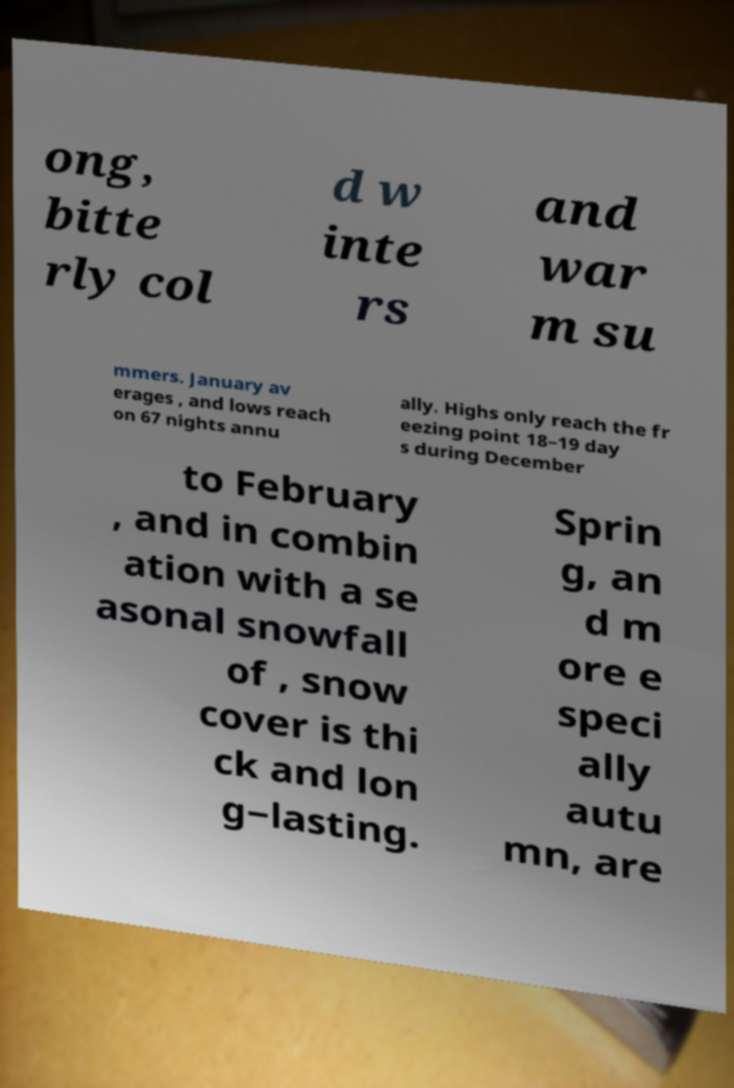There's text embedded in this image that I need extracted. Can you transcribe it verbatim? ong, bitte rly col d w inte rs and war m su mmers. January av erages , and lows reach on 67 nights annu ally. Highs only reach the fr eezing point 18–19 day s during December to February , and in combin ation with a se asonal snowfall of , snow cover is thi ck and lon g−lasting. Sprin g, an d m ore e speci ally autu mn, are 